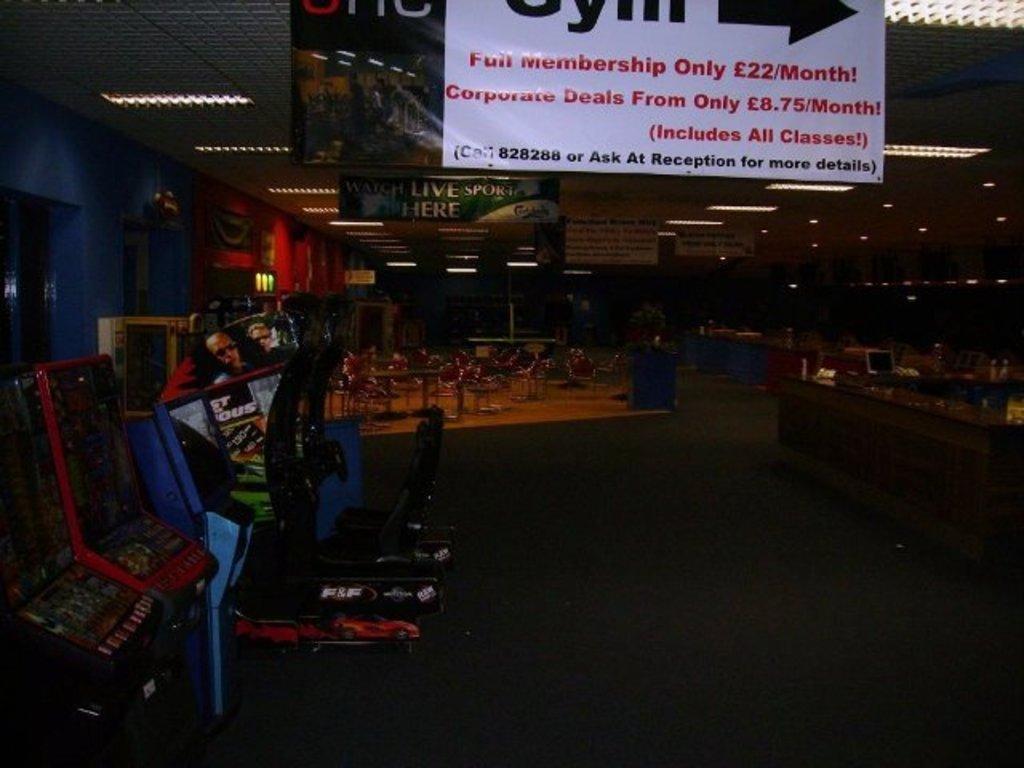Please provide a concise description of this image. On the left side of the image we can see a few gaming machines. At the top of the image, there is a banner with some text. In the background there is a wall, lights, chairs and a few other objects. 